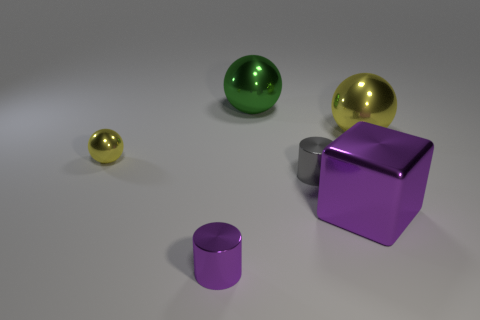How many other things are there of the same material as the gray object?
Provide a short and direct response. 5. There is a big metal thing that is the same color as the small shiny sphere; what is its shape?
Ensure brevity in your answer.  Sphere. There is a green metal sphere; does it have the same size as the yellow shiny sphere left of the small purple cylinder?
Make the answer very short. No. The cube that is the same material as the gray object is what size?
Make the answer very short. Large. Are there any cylinders that have the same color as the cube?
Your answer should be compact. Yes. Is the number of green things greater than the number of tiny red balls?
Give a very brief answer. Yes. What size is the shiny object that is the same color as the metallic block?
Your answer should be very brief. Small. Is there a gray thing made of the same material as the big yellow thing?
Your answer should be very brief. Yes. The shiny thing that is behind the small yellow shiny thing and left of the purple cube has what shape?
Offer a terse response. Sphere. How many other things are the same shape as the big purple metal object?
Provide a succinct answer. 0. 